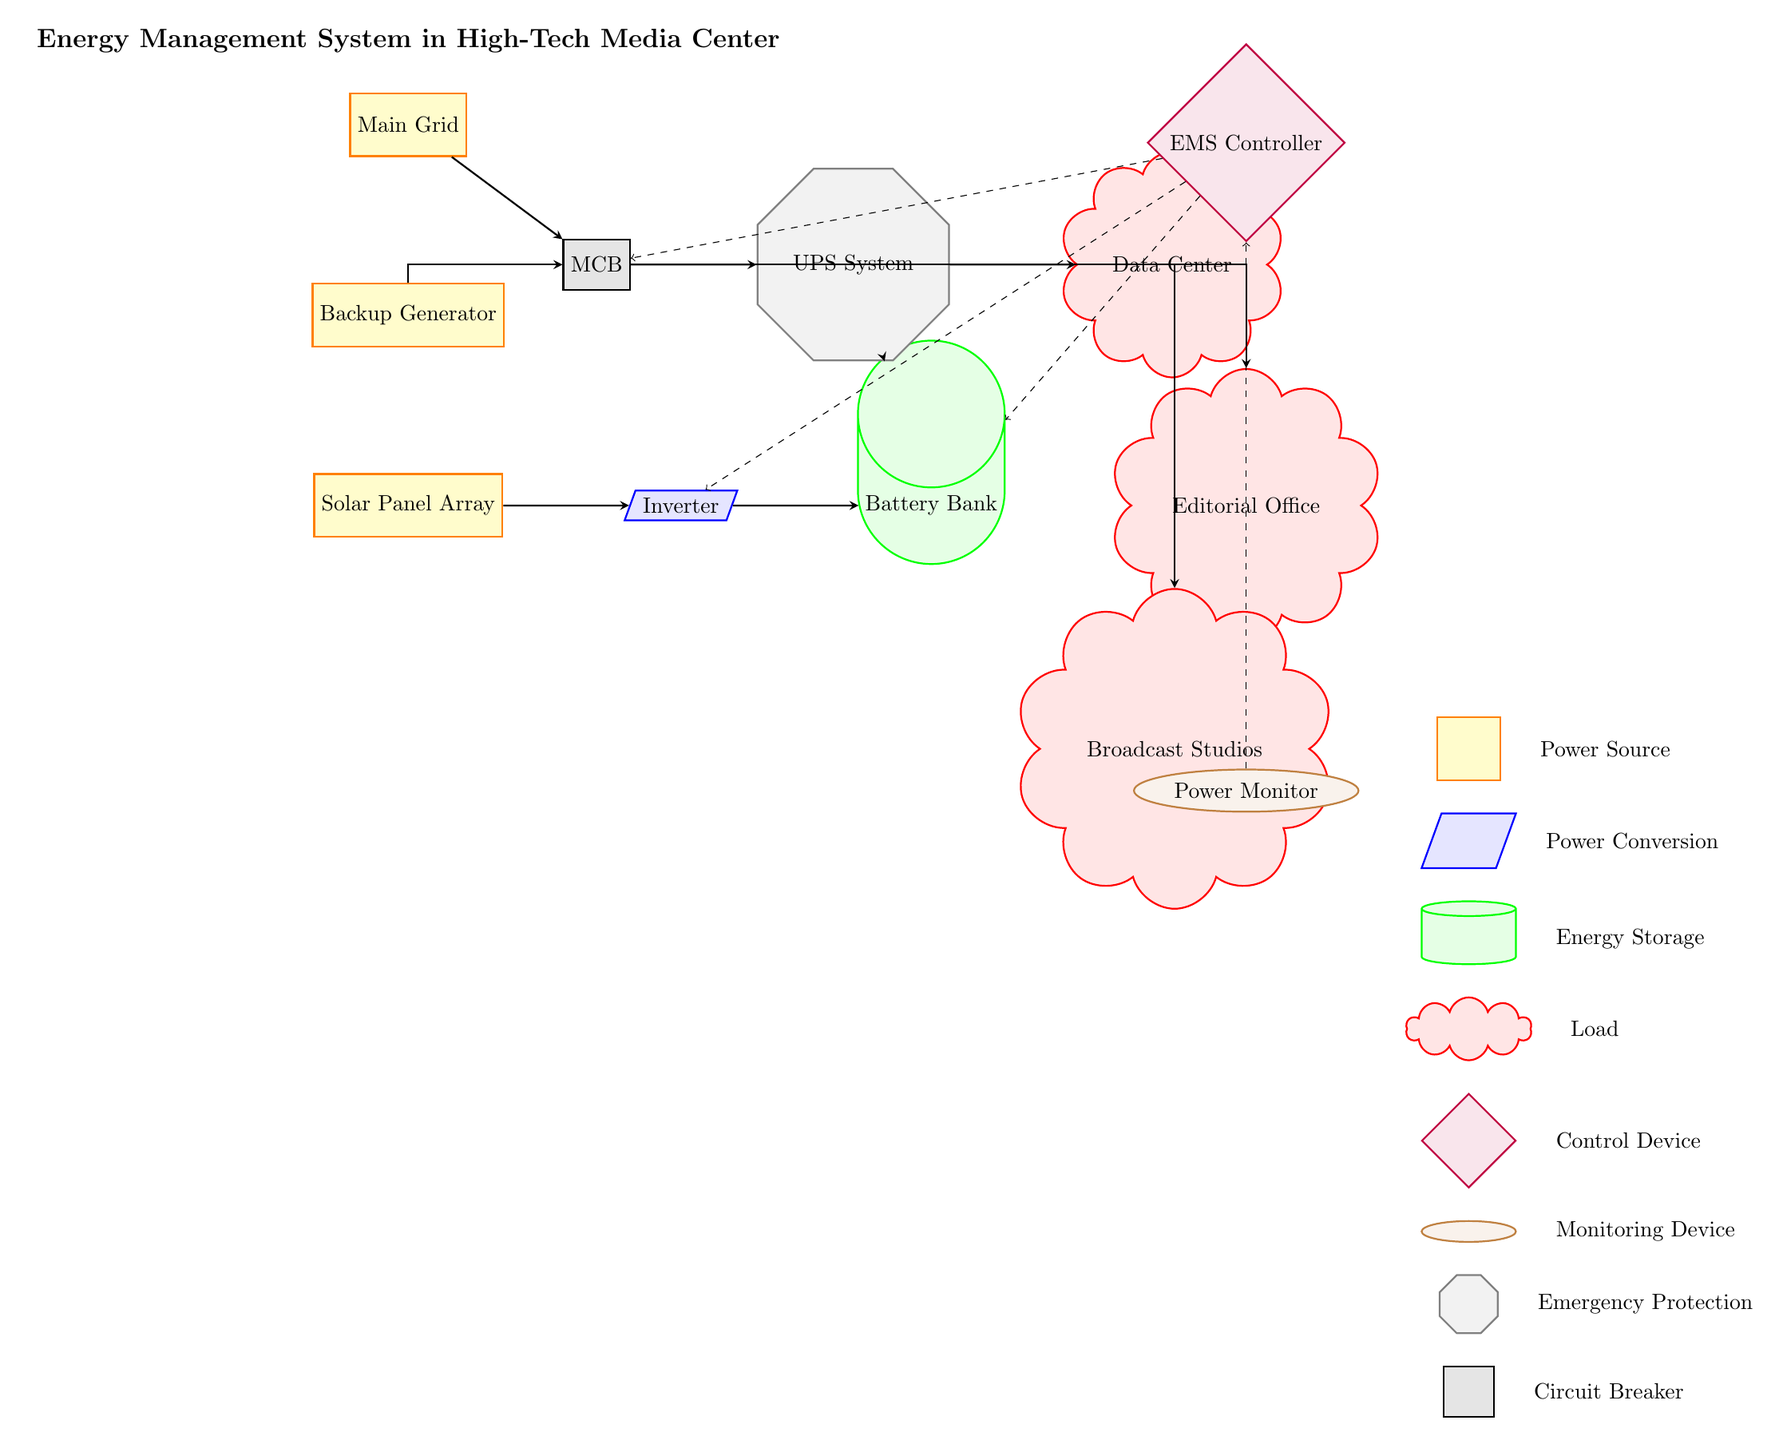What is the primary power source for the system? The diagram indicates that the "Main Grid" is the primary power source, as it is the topmost node from which other connections originate.
Answer: Main Grid How many loads are connected to the battery bank? The battery bank has three loads connected to it: the Data Center, the Editorial Office, and the Broadcast Studios. This can be counted directly from the connecting lines to the load nodes.
Answer: Three What type of device is the EMS Controller? The EMS Controller is represented by a diamond shape in the diagram, indicating its function as a control device within the energy management system.
Answer: Control Device Where does the energy from the solar panel array go first? The energy from the Solar Panel Array is directed to the Inverter, as depicted by the direct arrow connection in the diagram.
Answer: Inverter Which component provides emergency protection in the circuit? The UPS System is highlighted as providing emergency protection, indicated by its placement and shape (an octagon) in the diagram.
Answer: UPS System What is the purpose of the Inverter in this system? The Inverter's role is to convert energy from the Solar Panel Array into a usable form for the Battery Bank and subsequently for the loads. This is inferred from its position and connection in the flow of power.
Answer: Power Conversion Which power source has a backup capability? The Backup Generator serves as the power source with backup capabilities, as indicated by its placement beneath the Main Grid and work in conjunction with it.
Answer: Backup Generator Which two components are directly monitored by the Power Monitor? The Power Monitor is shown with dashed lines connecting it to both the EMS Controller and the breakers, indicating that it monitors those two components directly.
Answer: EMS Controller and MCB What is the shape of the Battery Bank in the diagram? The Battery Bank is depicted as a cylinder in the diagram, which is a common representation for storage elements in electrical circuits.
Answer: Cylinder 